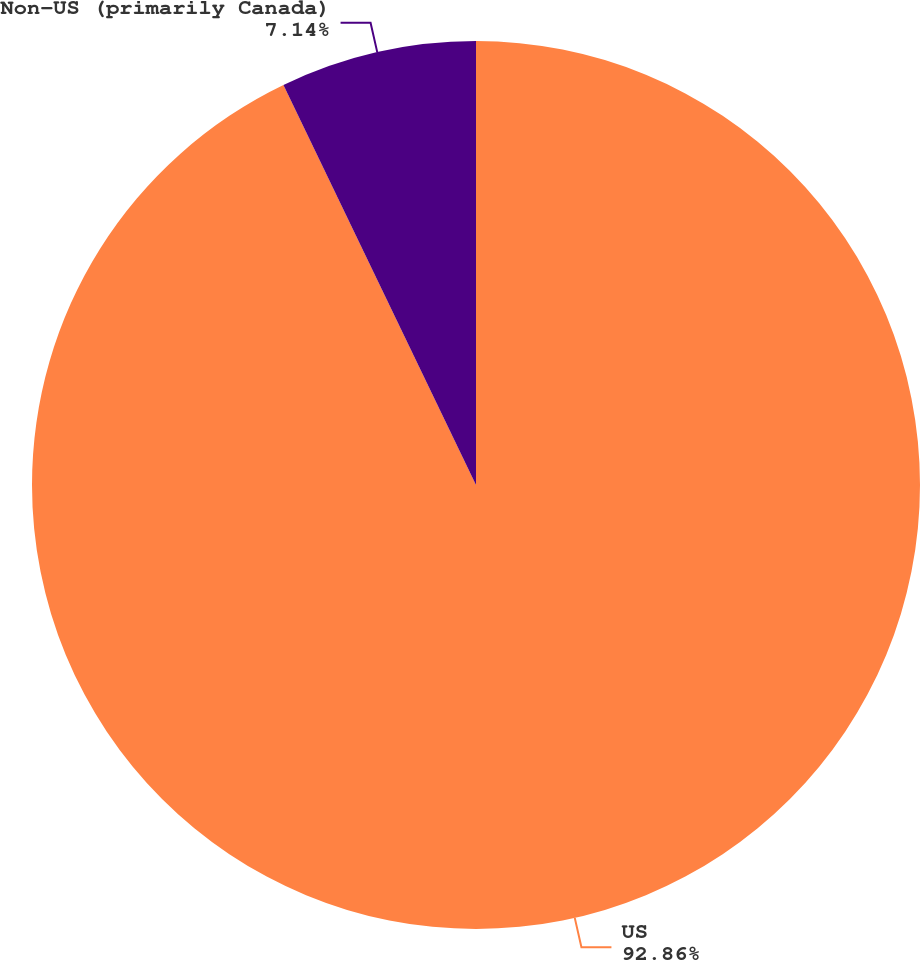Convert chart to OTSL. <chart><loc_0><loc_0><loc_500><loc_500><pie_chart><fcel>US<fcel>Non-US (primarily Canada)<nl><fcel>92.86%<fcel>7.14%<nl></chart> 